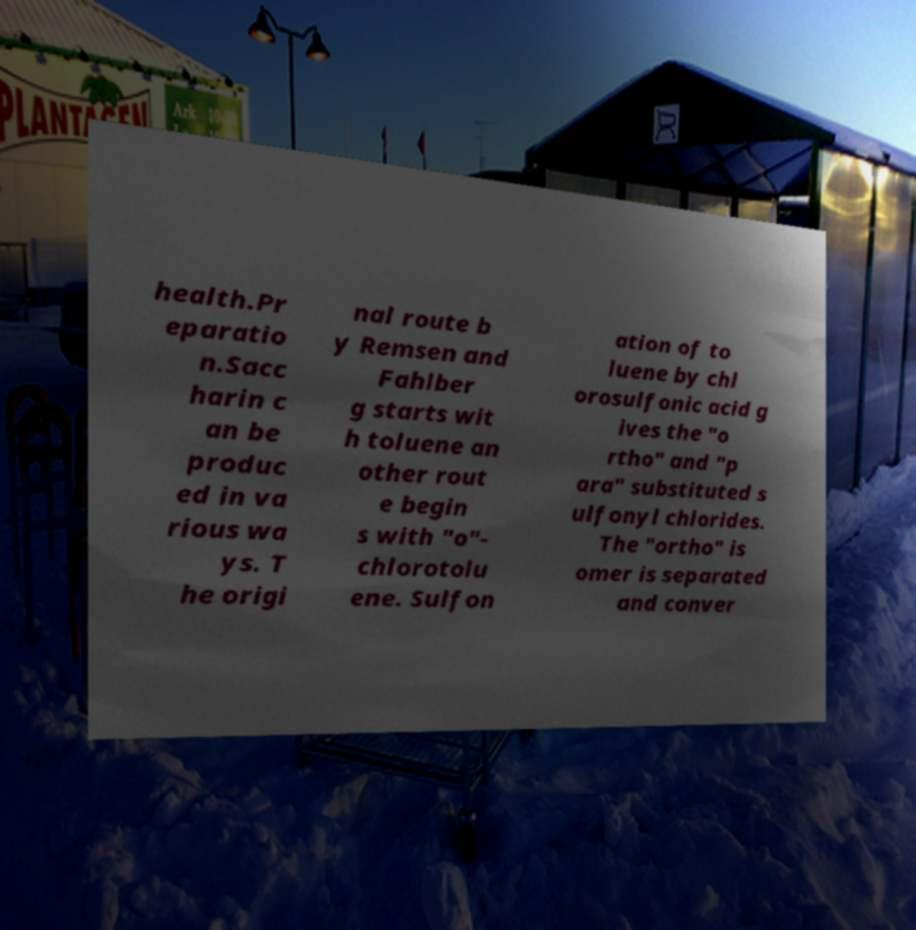Could you assist in decoding the text presented in this image and type it out clearly? health.Pr eparatio n.Sacc harin c an be produc ed in va rious wa ys. T he origi nal route b y Remsen and Fahlber g starts wit h toluene an other rout e begin s with "o"- chlorotolu ene. Sulfon ation of to luene by chl orosulfonic acid g ives the "o rtho" and "p ara" substituted s ulfonyl chlorides. The "ortho" is omer is separated and conver 